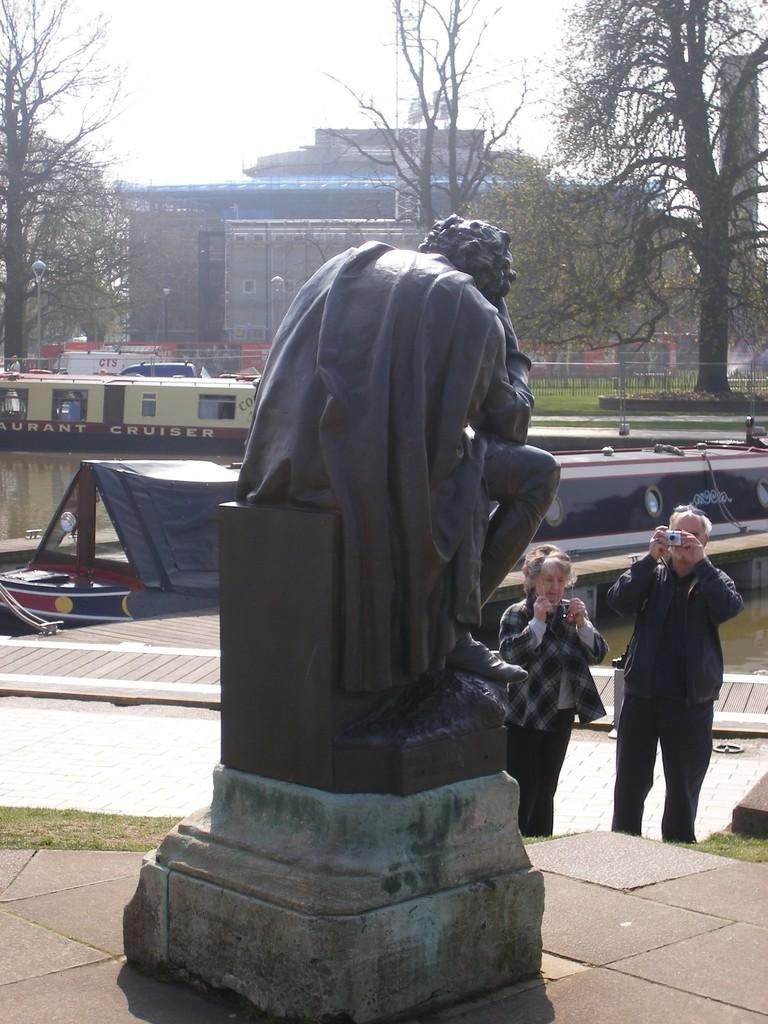What is the main subject in the image? There is a statue in the image. What are the two persons in the image doing? They are holding cameras in the image. What can be seen in the background of the image? There are boats, water, trees, a building, and the sky visible in the background of the image. What type of hair advice can be seen in the image? There is no hair advice present in the image. What disease is being treated by the statue in the image? There is no disease mentioned or depicted in the image; it is a statue. 